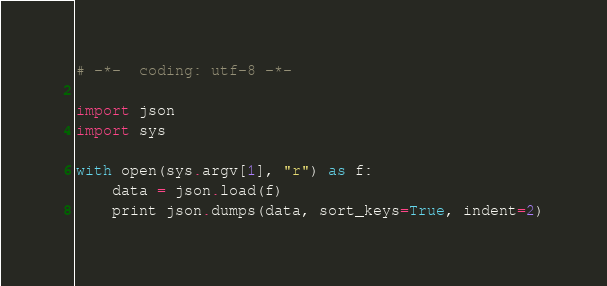Convert code to text. <code><loc_0><loc_0><loc_500><loc_500><_Python_># -*-  coding: utf-8 -*-

import json
import sys

with open(sys.argv[1], "r") as f:
    data = json.load(f)
    print json.dumps(data, sort_keys=True, indent=2)

</code> 